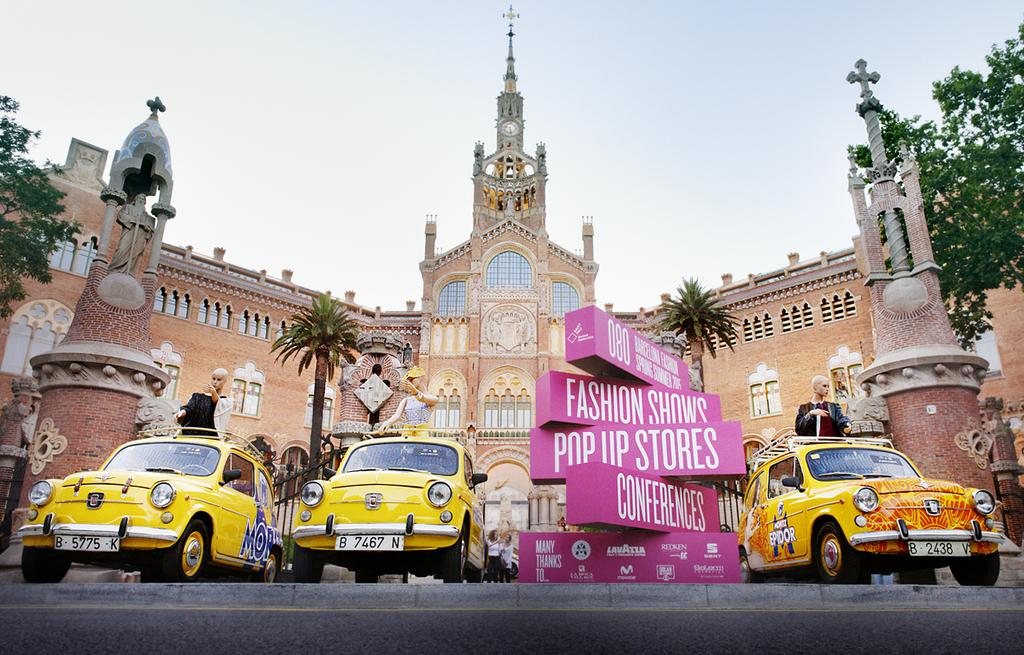Provide a one-sentence caption for the provided image. The pink Fashion Shows Pop Up Stores Conferences sign is displayed along with 3 yellow cars before a grand and beautiful building. 